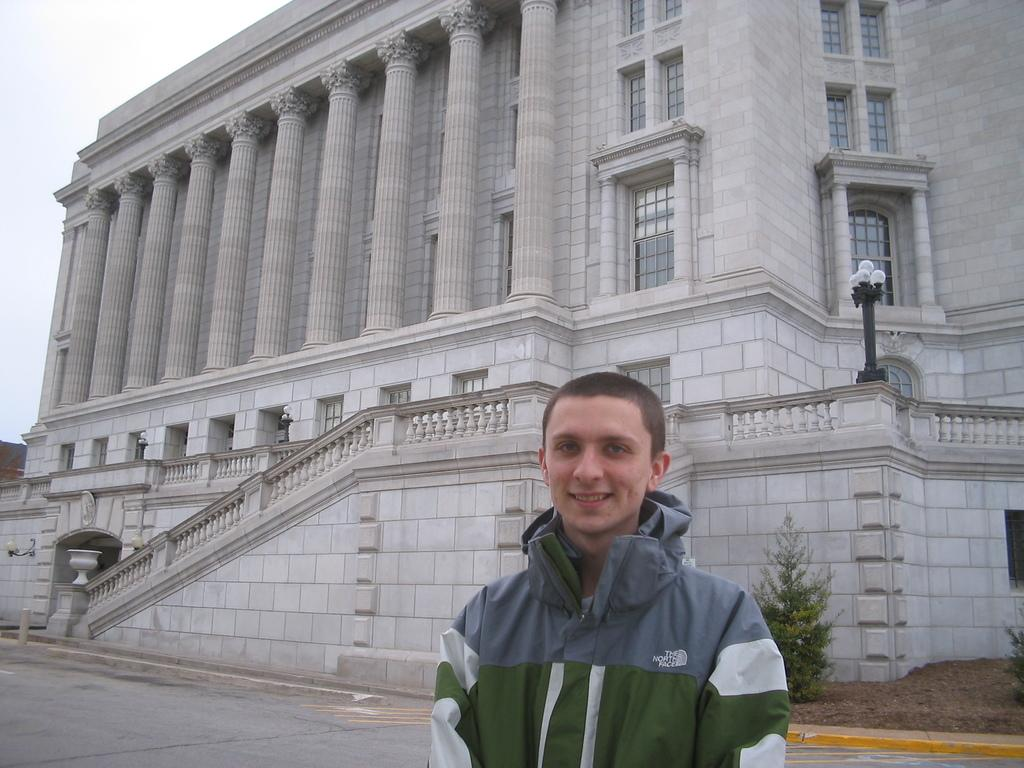<image>
Give a short and clear explanation of the subsequent image. A guy in a North Face jacket stands in front of a building. 